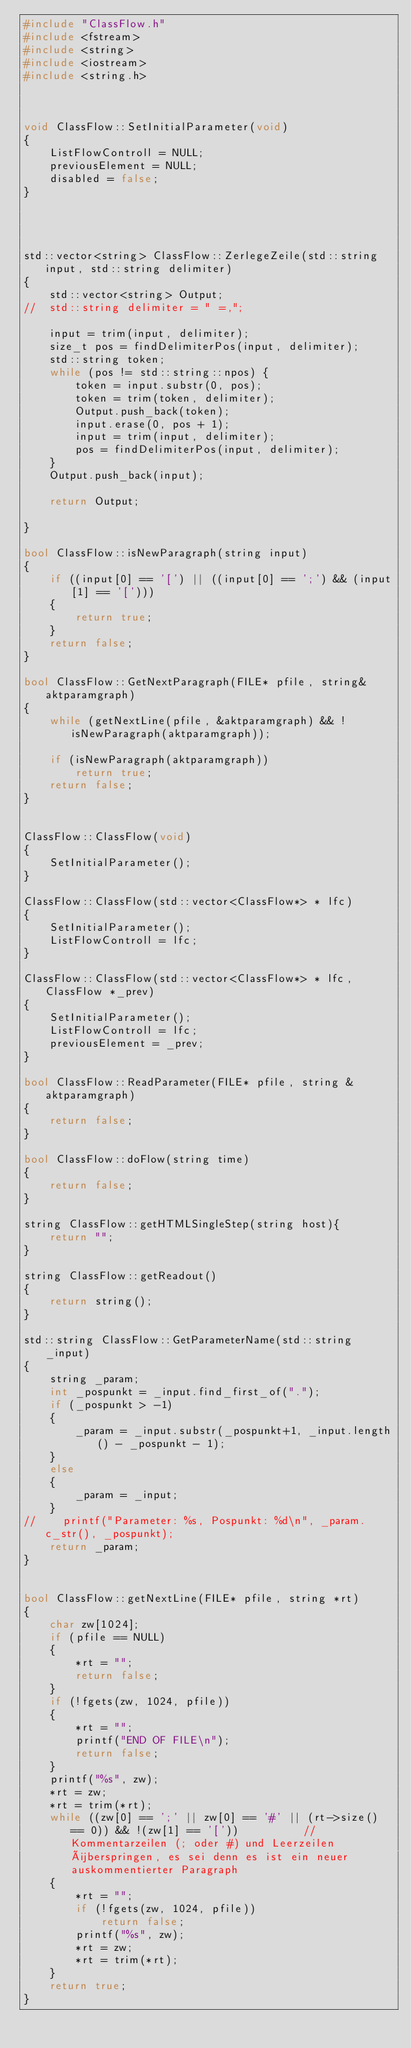<code> <loc_0><loc_0><loc_500><loc_500><_C++_>#include "ClassFlow.h"
#include <fstream>
#include <string>
#include <iostream>
#include <string.h>



void ClassFlow::SetInitialParameter(void)
{
	ListFlowControll = NULL;
	previousElement = NULL;	
	disabled = false;
}




std::vector<string> ClassFlow::ZerlegeZeile(std::string input, std::string delimiter)
{
	std::vector<string> Output;
//	std::string delimiter = " =,";

	input = trim(input, delimiter);
	size_t pos = findDelimiterPos(input, delimiter);
	std::string token;
	while (pos != std::string::npos) {
		token = input.substr(0, pos);
		token = trim(token, delimiter);
		Output.push_back(token);
		input.erase(0, pos + 1);
		input = trim(input, delimiter);
		pos = findDelimiterPos(input, delimiter);
	}
	Output.push_back(input);

	return Output;

}

bool ClassFlow::isNewParagraph(string input)
{
	if ((input[0] == '[') || ((input[0] == ';') && (input[1] == '[')))
	{
		return true;
	}
	return false;
}

bool ClassFlow::GetNextParagraph(FILE* pfile, string& aktparamgraph)
{
	while (getNextLine(pfile, &aktparamgraph) && !isNewParagraph(aktparamgraph));

	if (isNewParagraph(aktparamgraph))
		return true;
	return false;
}


ClassFlow::ClassFlow(void)
{
	SetInitialParameter();
}

ClassFlow::ClassFlow(std::vector<ClassFlow*> * lfc)
{
	SetInitialParameter();	
	ListFlowControll = lfc;
}

ClassFlow::ClassFlow(std::vector<ClassFlow*> * lfc, ClassFlow *_prev)
{
	SetInitialParameter();	
	ListFlowControll = lfc;
	previousElement = _prev;
}	

bool ClassFlow::ReadParameter(FILE* pfile, string &aktparamgraph)
{
	return false;
}

bool ClassFlow::doFlow(string time)
{
	return false;
}

string ClassFlow::getHTMLSingleStep(string host){
	return "";
}

string ClassFlow::getReadout()
{
	return string();
}

std::string ClassFlow::GetParameterName(std::string _input)
{
    string _param;
    int _pospunkt = _input.find_first_of(".");
    if (_pospunkt > -1)
    {
        _param = _input.substr(_pospunkt+1, _input.length() - _pospunkt - 1);
    }
    else
    {
        _param = _input;
    }
//    printf("Parameter: %s, Pospunkt: %d\n", _param.c_str(), _pospunkt);
	return _param;
}


bool ClassFlow::getNextLine(FILE* pfile, string *rt)
{
	char zw[1024];
	if (pfile == NULL)
	{
		*rt = "";
		return false;
	}
	if (!fgets(zw, 1024, pfile))
	{
		*rt = "";
		printf("END OF FILE\n");
		return false;
	}
	printf("%s", zw);
	*rt = zw;
	*rt = trim(*rt);
	while ((zw[0] == ';' || zw[0] == '#' || (rt->size() == 0)) && !(zw[1] == '['))			// Kommentarzeilen (; oder #) und Leerzeilen überspringen, es sei denn es ist ein neuer auskommentierter Paragraph
	{
		*rt = "";
		if (!fgets(zw, 1024, pfile))
			return false;
		printf("%s", zw);		
		*rt = zw;
		*rt = trim(*rt);
	}
	return true;
}
</code> 